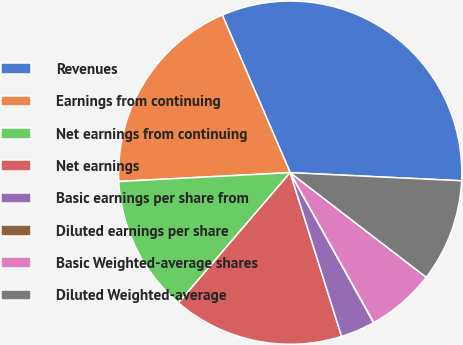<chart> <loc_0><loc_0><loc_500><loc_500><pie_chart><fcel>Revenues<fcel>Earnings from continuing<fcel>Net earnings from continuing<fcel>Net earnings<fcel>Basic earnings per share from<fcel>Diluted earnings per share<fcel>Basic Weighted-average shares<fcel>Diluted Weighted-average<nl><fcel>32.22%<fcel>19.34%<fcel>12.9%<fcel>16.12%<fcel>3.24%<fcel>0.02%<fcel>6.46%<fcel>9.68%<nl></chart> 